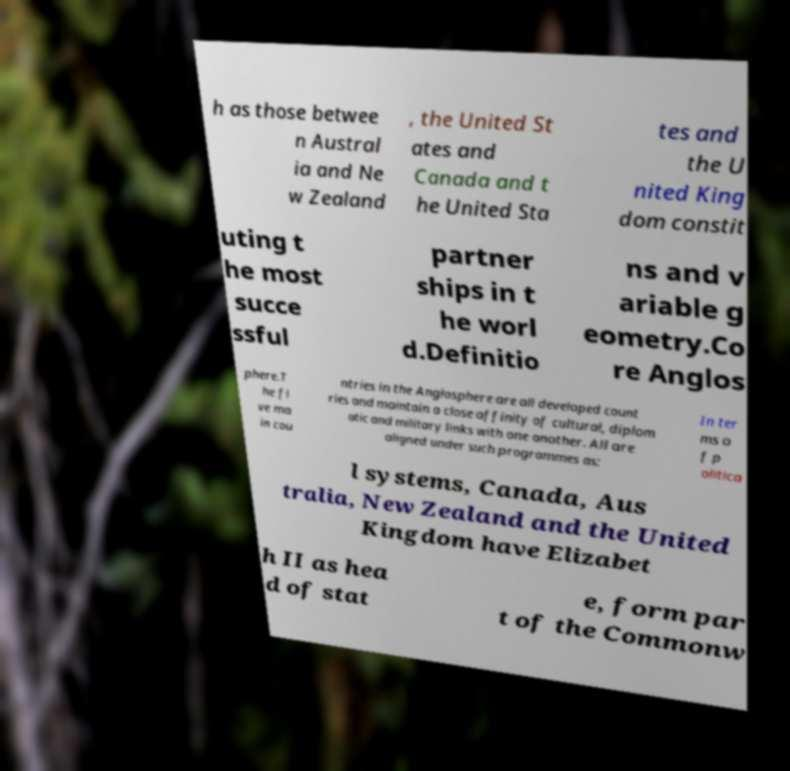Could you extract and type out the text from this image? h as those betwee n Austral ia and Ne w Zealand , the United St ates and Canada and t he United Sta tes and the U nited King dom constit uting t he most succe ssful partner ships in t he worl d.Definitio ns and v ariable g eometry.Co re Anglos phere.T he fi ve ma in cou ntries in the Anglosphere are all developed count ries and maintain a close affinity of cultural, diplom atic and military links with one another. All are aligned under such programmes as: In ter ms o f p olitica l systems, Canada, Aus tralia, New Zealand and the United Kingdom have Elizabet h II as hea d of stat e, form par t of the Commonw 